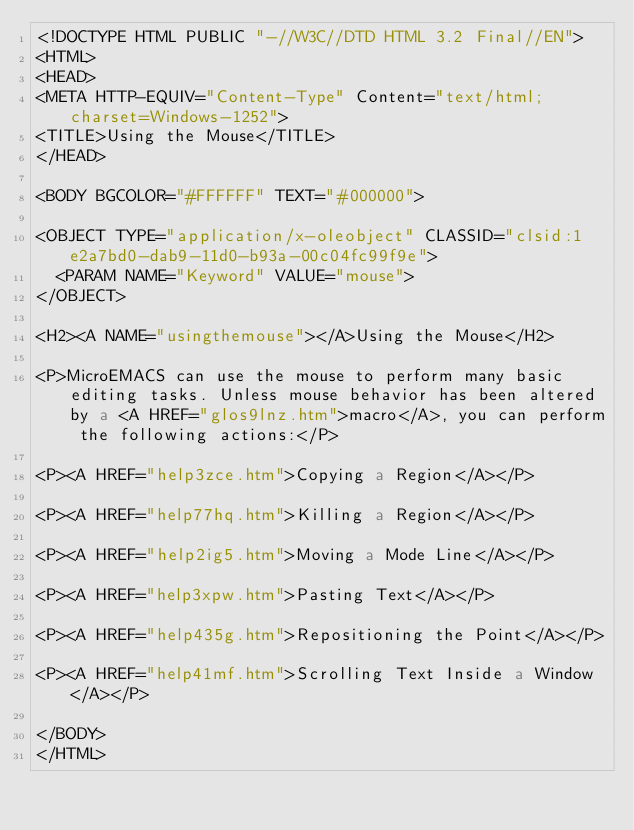<code> <loc_0><loc_0><loc_500><loc_500><_HTML_><!DOCTYPE HTML PUBLIC "-//W3C//DTD HTML 3.2 Final//EN">
<HTML>
<HEAD>
<META HTTP-EQUIV="Content-Type" Content="text/html; charset=Windows-1252">
<TITLE>Using the Mouse</TITLE>
</HEAD>

<BODY BGCOLOR="#FFFFFF" TEXT="#000000">

<OBJECT TYPE="application/x-oleobject" CLASSID="clsid:1e2a7bd0-dab9-11d0-b93a-00c04fc99f9e">
	<PARAM NAME="Keyword" VALUE="mouse">
</OBJECT>

<H2><A NAME="usingthemouse"></A>Using the Mouse</H2>

<P>MicroEMACS can use the mouse to perform many basic editing tasks. Unless mouse behavior has been altered by a <A HREF="glos9lnz.htm">macro</A>, you can perform the following actions:</P>

<P><A HREF="help3zce.htm">Copying a Region</A></P>

<P><A HREF="help77hq.htm">Killing a Region</A></P>

<P><A HREF="help2ig5.htm">Moving a Mode Line</A></P>

<P><A HREF="help3xpw.htm">Pasting Text</A></P>

<P><A HREF="help435g.htm">Repositioning the Point</A></P>

<P><A HREF="help41mf.htm">Scrolling Text Inside a Window</A></P>

</BODY>
</HTML>
</code> 